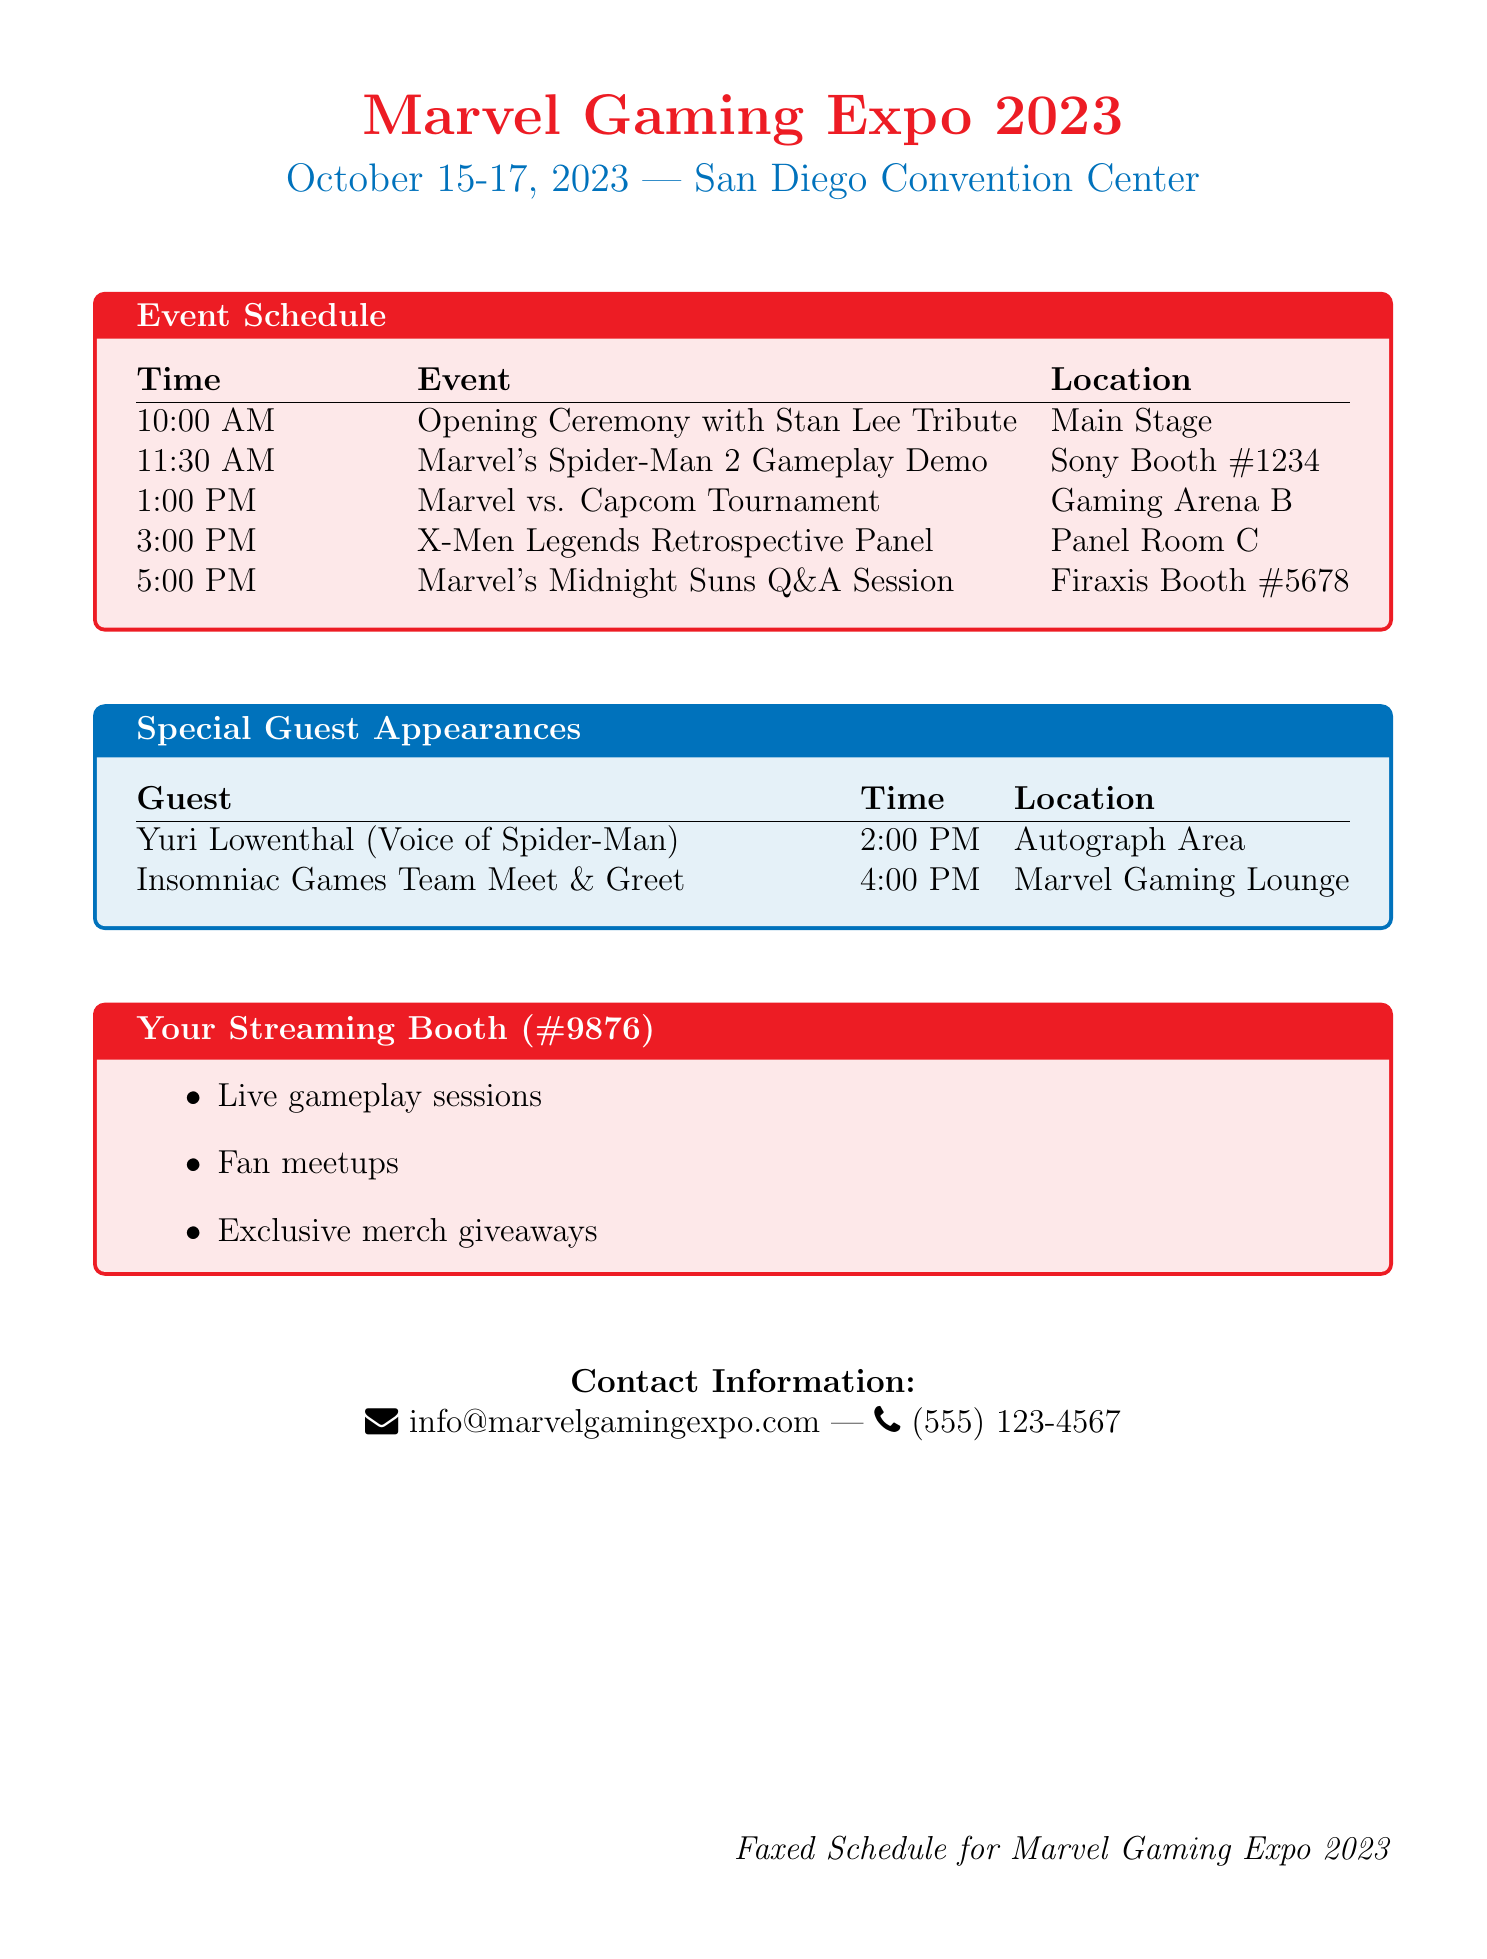What are the event dates? The event dates are specifically mentioned in the document header, showing the span of the convention.
Answer: October 15-17, 2023 Who is the special guest voice actor for Spider-Man? The document includes the name of the guest and their role, providing clear information.
Answer: Yuri Lowenthal What time does the Marvel's Midnight Suns Q&A Session start? The specific time for the Q&A session is listed in the event schedule for easy reference.
Answer: 5:00 PM Which booth is the Marvel vs. Capcom Tournament located at? The event schedule denotes the location of the tournament, allowing for clear navigation at the convention.
Answer: Gaming Arena B What is your streaming booth number? The fax specifies the booth number allocated to the streamer, which is important for identification at the event.
Answer: #9876 At what time is the Insomniac Games Team Meet & Greet scheduled? The schedule provides the time for this special event, helping attendees plan their day.
Answer: 4:00 PM How many events are scheduled before 3:00 PM? By analyzing the specified event times, we can determine the number of occurrences within that timeframe.
Answer: 3 What type of activities will be happening at the streaming booth? The booth information includes various activities planned, highlighting the interactive nature of the streaming booth.
Answer: Live gameplay sessions, Fan meetups, Exclusive merch giveaways Where can attendees find the contact information for the Expo? The document provides a clear section with the contact details, which is vital for inquiries.
Answer: At the bottom of the document 